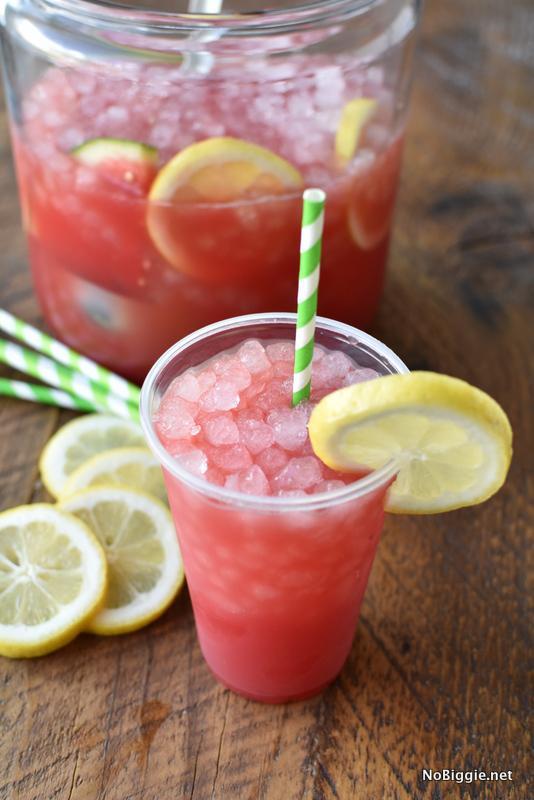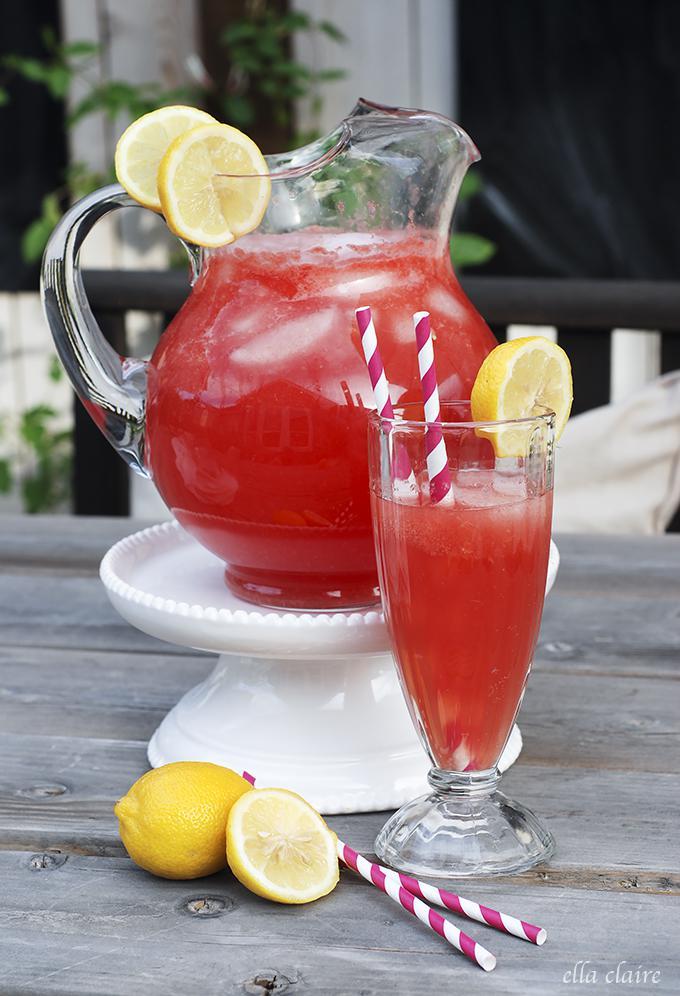The first image is the image on the left, the second image is the image on the right. Assess this claim about the two images: "Fruity drinks are garnished with fruit and striped straws.". Correct or not? Answer yes or no. Yes. The first image is the image on the left, the second image is the image on the right. Considering the images on both sides, is "All the images show drinks with straws in them." valid? Answer yes or no. Yes. 